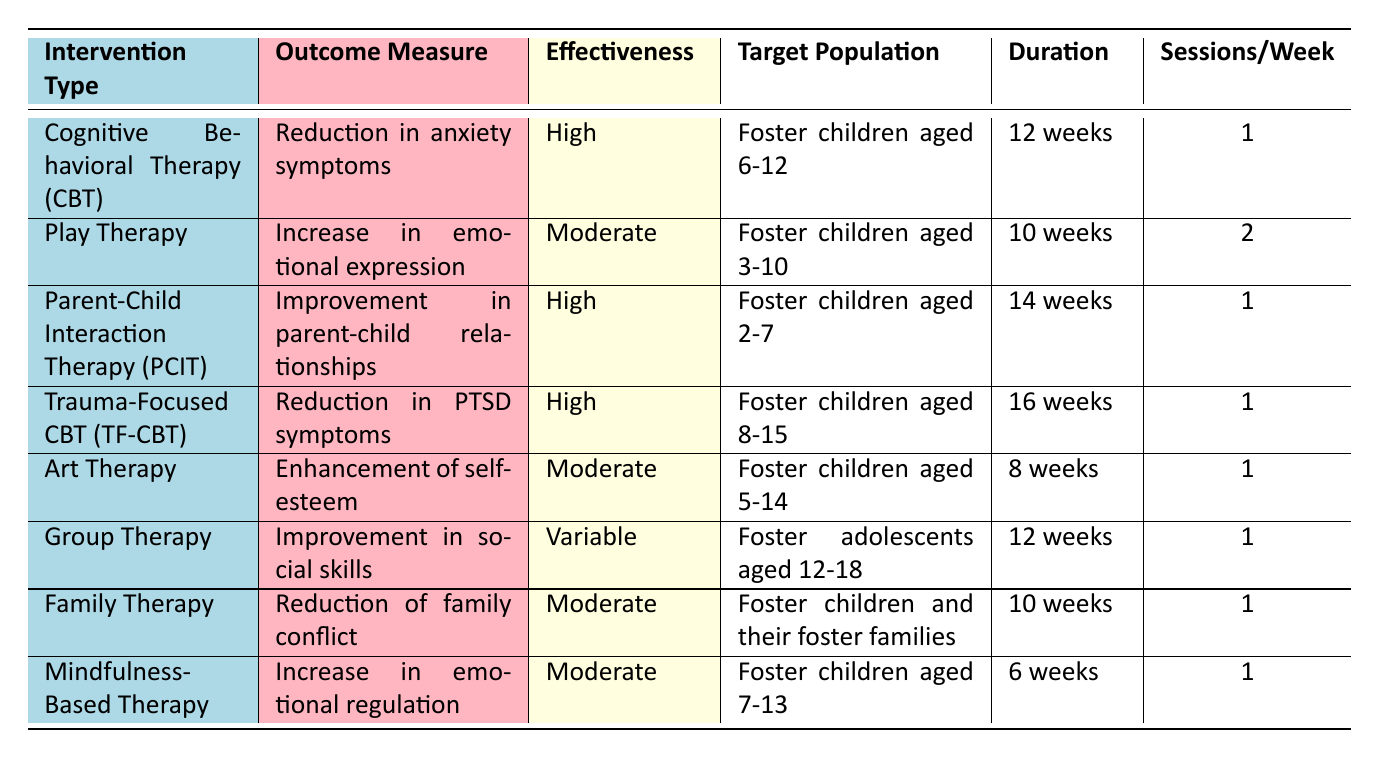What is the effectiveness rating of Art Therapy? Art Therapy is listed in the table with an effectiveness rating of "Moderate."
Answer: Moderate How many sessions per week are required for Trauma-Focused Cognitive Behavioral Therapy? According to the table, Trauma-Focused CBT requires 1 session per week.
Answer: 1 Which intervention has the longest duration? Looking through the table, Trauma-Focused CBT lasts for 16 weeks, which is the longest duration compared to the other interventions.
Answer: 16 weeks Is Parent-Child Interaction Therapy effective for children aged 6-12? Parent-Child Interaction Therapy targets children aged 2-7, so it is not effective for children aged 6-12.
Answer: No What is the average duration of the listed interventions? Summing the durations: 12 (CBT) + 10 (Play) + 14 (PCIT) + 16 (TF-CBT) + 8 (Art) + 12 (Group) + 10 (Family) + 6 (Mindfulness) = 88 weeks. There are 8 interventions, so the average duration is 88/8 = 11 weeks.
Answer: 11 weeks For which intervention is the improvement in parent-child relationships the outcome measure? The outcome measure of "Improvement in parent-child relationships" is specifically associated with Parent-Child Interaction Therapy (PCIT).
Answer: Parent-Child Interaction Therapy (PCIT) Which intervention has variable effectiveness, and what is its outcome measure? Group Therapy has variable effectiveness, and its outcome measure is "Improvement in social skills."
Answer: Group Therapy, Improvement in social skills Is there an intervention designed specifically for children younger than 3 years old? None of the listed interventions specifically target children younger than 3 years old, as the youngest targeted group starts at age 2.
Answer: No 